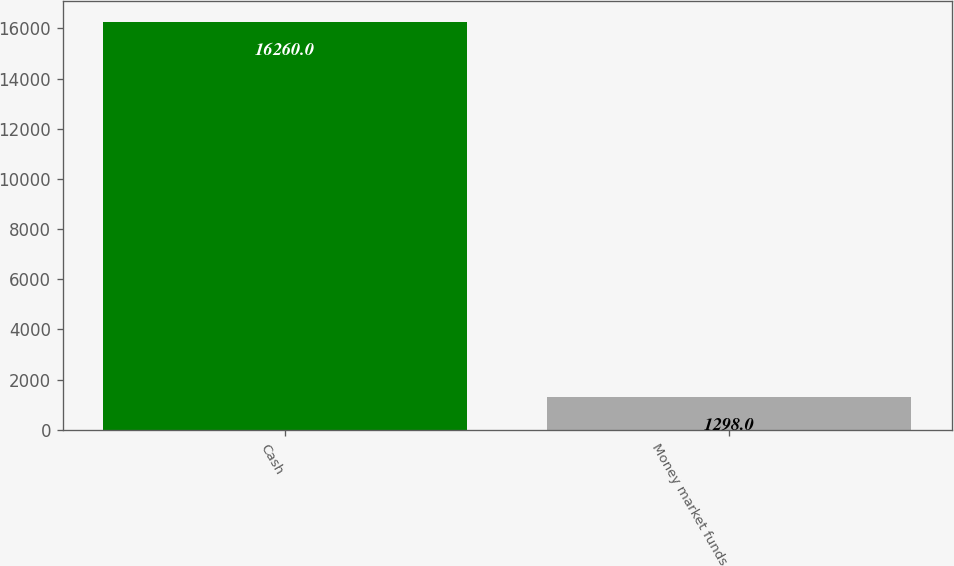Convert chart. <chart><loc_0><loc_0><loc_500><loc_500><bar_chart><fcel>Cash<fcel>Money market funds<nl><fcel>16260<fcel>1298<nl></chart> 